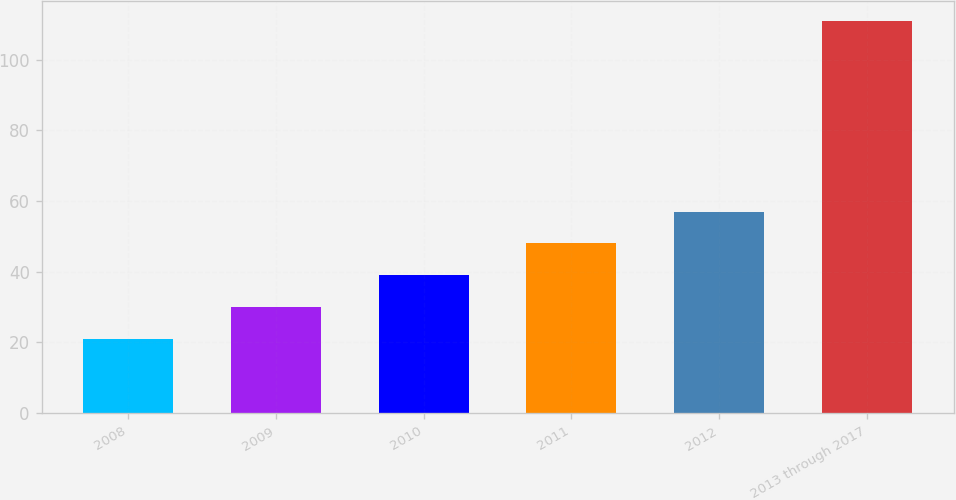<chart> <loc_0><loc_0><loc_500><loc_500><bar_chart><fcel>2008<fcel>2009<fcel>2010<fcel>2011<fcel>2012<fcel>2013 through 2017<nl><fcel>21<fcel>30<fcel>39<fcel>48<fcel>57<fcel>111<nl></chart> 